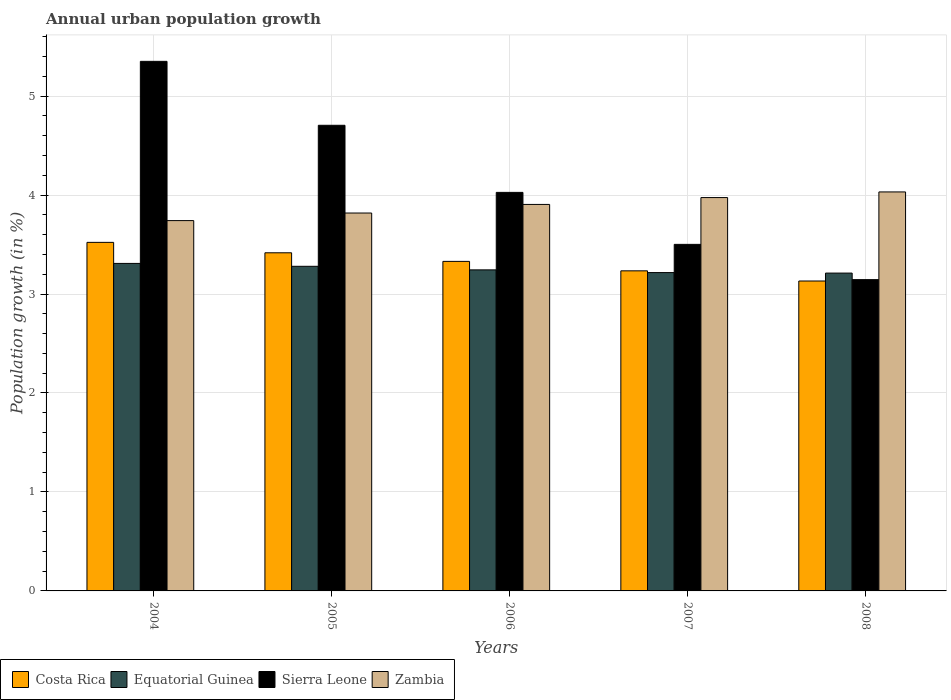How many different coloured bars are there?
Your response must be concise. 4. Are the number of bars on each tick of the X-axis equal?
Ensure brevity in your answer.  Yes. How many bars are there on the 5th tick from the right?
Provide a short and direct response. 4. What is the label of the 4th group of bars from the left?
Your answer should be very brief. 2007. What is the percentage of urban population growth in Zambia in 2007?
Offer a very short reply. 3.97. Across all years, what is the maximum percentage of urban population growth in Sierra Leone?
Offer a terse response. 5.35. Across all years, what is the minimum percentage of urban population growth in Zambia?
Make the answer very short. 3.74. What is the total percentage of urban population growth in Equatorial Guinea in the graph?
Your response must be concise. 16.26. What is the difference between the percentage of urban population growth in Sierra Leone in 2006 and that in 2007?
Your response must be concise. 0.53. What is the difference between the percentage of urban population growth in Equatorial Guinea in 2008 and the percentage of urban population growth in Costa Rica in 2005?
Your response must be concise. -0.21. What is the average percentage of urban population growth in Sierra Leone per year?
Make the answer very short. 4.15. In the year 2007, what is the difference between the percentage of urban population growth in Zambia and percentage of urban population growth in Costa Rica?
Your answer should be compact. 0.74. What is the ratio of the percentage of urban population growth in Sierra Leone in 2004 to that in 2006?
Offer a terse response. 1.33. Is the percentage of urban population growth in Zambia in 2004 less than that in 2008?
Your answer should be compact. Yes. What is the difference between the highest and the second highest percentage of urban population growth in Sierra Leone?
Give a very brief answer. 0.65. What is the difference between the highest and the lowest percentage of urban population growth in Costa Rica?
Your response must be concise. 0.39. Is the sum of the percentage of urban population growth in Zambia in 2006 and 2007 greater than the maximum percentage of urban population growth in Costa Rica across all years?
Give a very brief answer. Yes. What does the 3rd bar from the left in 2008 represents?
Provide a short and direct response. Sierra Leone. What does the 4th bar from the right in 2004 represents?
Your answer should be compact. Costa Rica. How many bars are there?
Ensure brevity in your answer.  20. Are the values on the major ticks of Y-axis written in scientific E-notation?
Offer a very short reply. No. What is the title of the graph?
Make the answer very short. Annual urban population growth. Does "Pakistan" appear as one of the legend labels in the graph?
Ensure brevity in your answer.  No. What is the label or title of the Y-axis?
Make the answer very short. Population growth (in %). What is the Population growth (in %) in Costa Rica in 2004?
Your answer should be very brief. 3.52. What is the Population growth (in %) of Equatorial Guinea in 2004?
Offer a terse response. 3.31. What is the Population growth (in %) of Sierra Leone in 2004?
Your answer should be compact. 5.35. What is the Population growth (in %) of Zambia in 2004?
Your answer should be compact. 3.74. What is the Population growth (in %) of Costa Rica in 2005?
Make the answer very short. 3.42. What is the Population growth (in %) of Equatorial Guinea in 2005?
Your response must be concise. 3.28. What is the Population growth (in %) in Sierra Leone in 2005?
Provide a succinct answer. 4.7. What is the Population growth (in %) of Zambia in 2005?
Your response must be concise. 3.82. What is the Population growth (in %) in Costa Rica in 2006?
Provide a succinct answer. 3.33. What is the Population growth (in %) in Equatorial Guinea in 2006?
Provide a succinct answer. 3.24. What is the Population growth (in %) of Sierra Leone in 2006?
Offer a terse response. 4.03. What is the Population growth (in %) in Zambia in 2006?
Offer a very short reply. 3.91. What is the Population growth (in %) of Costa Rica in 2007?
Provide a short and direct response. 3.23. What is the Population growth (in %) of Equatorial Guinea in 2007?
Your answer should be compact. 3.22. What is the Population growth (in %) of Sierra Leone in 2007?
Ensure brevity in your answer.  3.5. What is the Population growth (in %) of Zambia in 2007?
Give a very brief answer. 3.97. What is the Population growth (in %) of Costa Rica in 2008?
Offer a very short reply. 3.13. What is the Population growth (in %) in Equatorial Guinea in 2008?
Your answer should be very brief. 3.21. What is the Population growth (in %) of Sierra Leone in 2008?
Give a very brief answer. 3.15. What is the Population growth (in %) in Zambia in 2008?
Give a very brief answer. 4.03. Across all years, what is the maximum Population growth (in %) of Costa Rica?
Give a very brief answer. 3.52. Across all years, what is the maximum Population growth (in %) of Equatorial Guinea?
Your answer should be compact. 3.31. Across all years, what is the maximum Population growth (in %) of Sierra Leone?
Keep it short and to the point. 5.35. Across all years, what is the maximum Population growth (in %) of Zambia?
Provide a succinct answer. 4.03. Across all years, what is the minimum Population growth (in %) in Costa Rica?
Give a very brief answer. 3.13. Across all years, what is the minimum Population growth (in %) of Equatorial Guinea?
Your response must be concise. 3.21. Across all years, what is the minimum Population growth (in %) in Sierra Leone?
Offer a very short reply. 3.15. Across all years, what is the minimum Population growth (in %) in Zambia?
Offer a very short reply. 3.74. What is the total Population growth (in %) in Costa Rica in the graph?
Provide a short and direct response. 16.63. What is the total Population growth (in %) of Equatorial Guinea in the graph?
Make the answer very short. 16.26. What is the total Population growth (in %) of Sierra Leone in the graph?
Your response must be concise. 20.73. What is the total Population growth (in %) in Zambia in the graph?
Provide a succinct answer. 19.47. What is the difference between the Population growth (in %) in Costa Rica in 2004 and that in 2005?
Provide a succinct answer. 0.11. What is the difference between the Population growth (in %) in Equatorial Guinea in 2004 and that in 2005?
Offer a terse response. 0.03. What is the difference between the Population growth (in %) of Sierra Leone in 2004 and that in 2005?
Ensure brevity in your answer.  0.65. What is the difference between the Population growth (in %) of Zambia in 2004 and that in 2005?
Provide a succinct answer. -0.08. What is the difference between the Population growth (in %) of Costa Rica in 2004 and that in 2006?
Provide a succinct answer. 0.19. What is the difference between the Population growth (in %) of Equatorial Guinea in 2004 and that in 2006?
Keep it short and to the point. 0.07. What is the difference between the Population growth (in %) of Sierra Leone in 2004 and that in 2006?
Offer a very short reply. 1.32. What is the difference between the Population growth (in %) in Zambia in 2004 and that in 2006?
Your answer should be compact. -0.16. What is the difference between the Population growth (in %) of Costa Rica in 2004 and that in 2007?
Provide a succinct answer. 0.29. What is the difference between the Population growth (in %) in Equatorial Guinea in 2004 and that in 2007?
Your answer should be compact. 0.09. What is the difference between the Population growth (in %) in Sierra Leone in 2004 and that in 2007?
Ensure brevity in your answer.  1.85. What is the difference between the Population growth (in %) of Zambia in 2004 and that in 2007?
Offer a very short reply. -0.23. What is the difference between the Population growth (in %) in Costa Rica in 2004 and that in 2008?
Ensure brevity in your answer.  0.39. What is the difference between the Population growth (in %) in Equatorial Guinea in 2004 and that in 2008?
Make the answer very short. 0.1. What is the difference between the Population growth (in %) in Sierra Leone in 2004 and that in 2008?
Offer a terse response. 2.21. What is the difference between the Population growth (in %) in Zambia in 2004 and that in 2008?
Your answer should be very brief. -0.29. What is the difference between the Population growth (in %) in Costa Rica in 2005 and that in 2006?
Provide a succinct answer. 0.09. What is the difference between the Population growth (in %) in Equatorial Guinea in 2005 and that in 2006?
Keep it short and to the point. 0.04. What is the difference between the Population growth (in %) of Sierra Leone in 2005 and that in 2006?
Provide a short and direct response. 0.68. What is the difference between the Population growth (in %) in Zambia in 2005 and that in 2006?
Keep it short and to the point. -0.09. What is the difference between the Population growth (in %) in Costa Rica in 2005 and that in 2007?
Keep it short and to the point. 0.18. What is the difference between the Population growth (in %) in Equatorial Guinea in 2005 and that in 2007?
Ensure brevity in your answer.  0.06. What is the difference between the Population growth (in %) of Sierra Leone in 2005 and that in 2007?
Your answer should be compact. 1.2. What is the difference between the Population growth (in %) in Zambia in 2005 and that in 2007?
Offer a terse response. -0.16. What is the difference between the Population growth (in %) in Costa Rica in 2005 and that in 2008?
Offer a terse response. 0.29. What is the difference between the Population growth (in %) of Equatorial Guinea in 2005 and that in 2008?
Keep it short and to the point. 0.07. What is the difference between the Population growth (in %) in Sierra Leone in 2005 and that in 2008?
Your answer should be very brief. 1.56. What is the difference between the Population growth (in %) of Zambia in 2005 and that in 2008?
Provide a short and direct response. -0.21. What is the difference between the Population growth (in %) of Costa Rica in 2006 and that in 2007?
Provide a succinct answer. 0.1. What is the difference between the Population growth (in %) in Equatorial Guinea in 2006 and that in 2007?
Give a very brief answer. 0.03. What is the difference between the Population growth (in %) in Sierra Leone in 2006 and that in 2007?
Give a very brief answer. 0.53. What is the difference between the Population growth (in %) of Zambia in 2006 and that in 2007?
Your answer should be compact. -0.07. What is the difference between the Population growth (in %) in Costa Rica in 2006 and that in 2008?
Provide a succinct answer. 0.2. What is the difference between the Population growth (in %) in Equatorial Guinea in 2006 and that in 2008?
Keep it short and to the point. 0.03. What is the difference between the Population growth (in %) in Sierra Leone in 2006 and that in 2008?
Ensure brevity in your answer.  0.88. What is the difference between the Population growth (in %) in Zambia in 2006 and that in 2008?
Give a very brief answer. -0.13. What is the difference between the Population growth (in %) in Costa Rica in 2007 and that in 2008?
Make the answer very short. 0.1. What is the difference between the Population growth (in %) of Equatorial Guinea in 2007 and that in 2008?
Keep it short and to the point. 0.01. What is the difference between the Population growth (in %) of Sierra Leone in 2007 and that in 2008?
Your response must be concise. 0.36. What is the difference between the Population growth (in %) in Zambia in 2007 and that in 2008?
Give a very brief answer. -0.06. What is the difference between the Population growth (in %) of Costa Rica in 2004 and the Population growth (in %) of Equatorial Guinea in 2005?
Provide a succinct answer. 0.24. What is the difference between the Population growth (in %) of Costa Rica in 2004 and the Population growth (in %) of Sierra Leone in 2005?
Make the answer very short. -1.18. What is the difference between the Population growth (in %) of Costa Rica in 2004 and the Population growth (in %) of Zambia in 2005?
Ensure brevity in your answer.  -0.3. What is the difference between the Population growth (in %) in Equatorial Guinea in 2004 and the Population growth (in %) in Sierra Leone in 2005?
Offer a terse response. -1.4. What is the difference between the Population growth (in %) of Equatorial Guinea in 2004 and the Population growth (in %) of Zambia in 2005?
Offer a terse response. -0.51. What is the difference between the Population growth (in %) in Sierra Leone in 2004 and the Population growth (in %) in Zambia in 2005?
Provide a short and direct response. 1.53. What is the difference between the Population growth (in %) of Costa Rica in 2004 and the Population growth (in %) of Equatorial Guinea in 2006?
Offer a terse response. 0.28. What is the difference between the Population growth (in %) of Costa Rica in 2004 and the Population growth (in %) of Sierra Leone in 2006?
Your answer should be very brief. -0.51. What is the difference between the Population growth (in %) of Costa Rica in 2004 and the Population growth (in %) of Zambia in 2006?
Make the answer very short. -0.38. What is the difference between the Population growth (in %) of Equatorial Guinea in 2004 and the Population growth (in %) of Sierra Leone in 2006?
Offer a very short reply. -0.72. What is the difference between the Population growth (in %) in Equatorial Guinea in 2004 and the Population growth (in %) in Zambia in 2006?
Your answer should be very brief. -0.6. What is the difference between the Population growth (in %) of Sierra Leone in 2004 and the Population growth (in %) of Zambia in 2006?
Provide a succinct answer. 1.45. What is the difference between the Population growth (in %) in Costa Rica in 2004 and the Population growth (in %) in Equatorial Guinea in 2007?
Provide a succinct answer. 0.31. What is the difference between the Population growth (in %) of Costa Rica in 2004 and the Population growth (in %) of Sierra Leone in 2007?
Your answer should be very brief. 0.02. What is the difference between the Population growth (in %) in Costa Rica in 2004 and the Population growth (in %) in Zambia in 2007?
Ensure brevity in your answer.  -0.45. What is the difference between the Population growth (in %) of Equatorial Guinea in 2004 and the Population growth (in %) of Sierra Leone in 2007?
Make the answer very short. -0.19. What is the difference between the Population growth (in %) in Equatorial Guinea in 2004 and the Population growth (in %) in Zambia in 2007?
Provide a short and direct response. -0.67. What is the difference between the Population growth (in %) of Sierra Leone in 2004 and the Population growth (in %) of Zambia in 2007?
Your answer should be very brief. 1.38. What is the difference between the Population growth (in %) of Costa Rica in 2004 and the Population growth (in %) of Equatorial Guinea in 2008?
Provide a succinct answer. 0.31. What is the difference between the Population growth (in %) in Costa Rica in 2004 and the Population growth (in %) in Sierra Leone in 2008?
Offer a terse response. 0.38. What is the difference between the Population growth (in %) in Costa Rica in 2004 and the Population growth (in %) in Zambia in 2008?
Give a very brief answer. -0.51. What is the difference between the Population growth (in %) of Equatorial Guinea in 2004 and the Population growth (in %) of Sierra Leone in 2008?
Your response must be concise. 0.16. What is the difference between the Population growth (in %) of Equatorial Guinea in 2004 and the Population growth (in %) of Zambia in 2008?
Ensure brevity in your answer.  -0.72. What is the difference between the Population growth (in %) in Sierra Leone in 2004 and the Population growth (in %) in Zambia in 2008?
Ensure brevity in your answer.  1.32. What is the difference between the Population growth (in %) in Costa Rica in 2005 and the Population growth (in %) in Equatorial Guinea in 2006?
Make the answer very short. 0.17. What is the difference between the Population growth (in %) of Costa Rica in 2005 and the Population growth (in %) of Sierra Leone in 2006?
Offer a terse response. -0.61. What is the difference between the Population growth (in %) in Costa Rica in 2005 and the Population growth (in %) in Zambia in 2006?
Offer a terse response. -0.49. What is the difference between the Population growth (in %) in Equatorial Guinea in 2005 and the Population growth (in %) in Sierra Leone in 2006?
Your answer should be very brief. -0.75. What is the difference between the Population growth (in %) of Equatorial Guinea in 2005 and the Population growth (in %) of Zambia in 2006?
Provide a short and direct response. -0.63. What is the difference between the Population growth (in %) in Sierra Leone in 2005 and the Population growth (in %) in Zambia in 2006?
Make the answer very short. 0.8. What is the difference between the Population growth (in %) of Costa Rica in 2005 and the Population growth (in %) of Sierra Leone in 2007?
Your answer should be very brief. -0.09. What is the difference between the Population growth (in %) of Costa Rica in 2005 and the Population growth (in %) of Zambia in 2007?
Provide a succinct answer. -0.56. What is the difference between the Population growth (in %) in Equatorial Guinea in 2005 and the Population growth (in %) in Sierra Leone in 2007?
Keep it short and to the point. -0.22. What is the difference between the Population growth (in %) of Equatorial Guinea in 2005 and the Population growth (in %) of Zambia in 2007?
Your answer should be very brief. -0.69. What is the difference between the Population growth (in %) of Sierra Leone in 2005 and the Population growth (in %) of Zambia in 2007?
Keep it short and to the point. 0.73. What is the difference between the Population growth (in %) in Costa Rica in 2005 and the Population growth (in %) in Equatorial Guinea in 2008?
Ensure brevity in your answer.  0.2. What is the difference between the Population growth (in %) of Costa Rica in 2005 and the Population growth (in %) of Sierra Leone in 2008?
Offer a terse response. 0.27. What is the difference between the Population growth (in %) of Costa Rica in 2005 and the Population growth (in %) of Zambia in 2008?
Offer a terse response. -0.61. What is the difference between the Population growth (in %) in Equatorial Guinea in 2005 and the Population growth (in %) in Sierra Leone in 2008?
Offer a very short reply. 0.13. What is the difference between the Population growth (in %) in Equatorial Guinea in 2005 and the Population growth (in %) in Zambia in 2008?
Ensure brevity in your answer.  -0.75. What is the difference between the Population growth (in %) in Sierra Leone in 2005 and the Population growth (in %) in Zambia in 2008?
Your response must be concise. 0.67. What is the difference between the Population growth (in %) of Costa Rica in 2006 and the Population growth (in %) of Equatorial Guinea in 2007?
Offer a very short reply. 0.11. What is the difference between the Population growth (in %) in Costa Rica in 2006 and the Population growth (in %) in Sierra Leone in 2007?
Offer a very short reply. -0.17. What is the difference between the Population growth (in %) of Costa Rica in 2006 and the Population growth (in %) of Zambia in 2007?
Make the answer very short. -0.64. What is the difference between the Population growth (in %) in Equatorial Guinea in 2006 and the Population growth (in %) in Sierra Leone in 2007?
Offer a terse response. -0.26. What is the difference between the Population growth (in %) in Equatorial Guinea in 2006 and the Population growth (in %) in Zambia in 2007?
Give a very brief answer. -0.73. What is the difference between the Population growth (in %) in Sierra Leone in 2006 and the Population growth (in %) in Zambia in 2007?
Give a very brief answer. 0.05. What is the difference between the Population growth (in %) in Costa Rica in 2006 and the Population growth (in %) in Equatorial Guinea in 2008?
Make the answer very short. 0.12. What is the difference between the Population growth (in %) of Costa Rica in 2006 and the Population growth (in %) of Sierra Leone in 2008?
Your answer should be very brief. 0.18. What is the difference between the Population growth (in %) in Costa Rica in 2006 and the Population growth (in %) in Zambia in 2008?
Give a very brief answer. -0.7. What is the difference between the Population growth (in %) in Equatorial Guinea in 2006 and the Population growth (in %) in Sierra Leone in 2008?
Your response must be concise. 0.1. What is the difference between the Population growth (in %) in Equatorial Guinea in 2006 and the Population growth (in %) in Zambia in 2008?
Your response must be concise. -0.79. What is the difference between the Population growth (in %) in Sierra Leone in 2006 and the Population growth (in %) in Zambia in 2008?
Give a very brief answer. -0. What is the difference between the Population growth (in %) in Costa Rica in 2007 and the Population growth (in %) in Equatorial Guinea in 2008?
Keep it short and to the point. 0.02. What is the difference between the Population growth (in %) in Costa Rica in 2007 and the Population growth (in %) in Sierra Leone in 2008?
Your answer should be compact. 0.09. What is the difference between the Population growth (in %) of Costa Rica in 2007 and the Population growth (in %) of Zambia in 2008?
Offer a terse response. -0.8. What is the difference between the Population growth (in %) in Equatorial Guinea in 2007 and the Population growth (in %) in Sierra Leone in 2008?
Your response must be concise. 0.07. What is the difference between the Population growth (in %) of Equatorial Guinea in 2007 and the Population growth (in %) of Zambia in 2008?
Your answer should be very brief. -0.81. What is the difference between the Population growth (in %) of Sierra Leone in 2007 and the Population growth (in %) of Zambia in 2008?
Provide a short and direct response. -0.53. What is the average Population growth (in %) in Costa Rica per year?
Offer a terse response. 3.33. What is the average Population growth (in %) in Equatorial Guinea per year?
Provide a short and direct response. 3.25. What is the average Population growth (in %) of Sierra Leone per year?
Give a very brief answer. 4.15. What is the average Population growth (in %) of Zambia per year?
Your answer should be compact. 3.89. In the year 2004, what is the difference between the Population growth (in %) of Costa Rica and Population growth (in %) of Equatorial Guinea?
Make the answer very short. 0.21. In the year 2004, what is the difference between the Population growth (in %) of Costa Rica and Population growth (in %) of Sierra Leone?
Your answer should be very brief. -1.83. In the year 2004, what is the difference between the Population growth (in %) in Costa Rica and Population growth (in %) in Zambia?
Your answer should be very brief. -0.22. In the year 2004, what is the difference between the Population growth (in %) of Equatorial Guinea and Population growth (in %) of Sierra Leone?
Make the answer very short. -2.04. In the year 2004, what is the difference between the Population growth (in %) of Equatorial Guinea and Population growth (in %) of Zambia?
Keep it short and to the point. -0.43. In the year 2004, what is the difference between the Population growth (in %) of Sierra Leone and Population growth (in %) of Zambia?
Ensure brevity in your answer.  1.61. In the year 2005, what is the difference between the Population growth (in %) of Costa Rica and Population growth (in %) of Equatorial Guinea?
Make the answer very short. 0.14. In the year 2005, what is the difference between the Population growth (in %) of Costa Rica and Population growth (in %) of Sierra Leone?
Offer a very short reply. -1.29. In the year 2005, what is the difference between the Population growth (in %) of Costa Rica and Population growth (in %) of Zambia?
Ensure brevity in your answer.  -0.4. In the year 2005, what is the difference between the Population growth (in %) in Equatorial Guinea and Population growth (in %) in Sierra Leone?
Your answer should be compact. -1.42. In the year 2005, what is the difference between the Population growth (in %) of Equatorial Guinea and Population growth (in %) of Zambia?
Offer a very short reply. -0.54. In the year 2005, what is the difference between the Population growth (in %) in Sierra Leone and Population growth (in %) in Zambia?
Your answer should be very brief. 0.89. In the year 2006, what is the difference between the Population growth (in %) of Costa Rica and Population growth (in %) of Equatorial Guinea?
Keep it short and to the point. 0.09. In the year 2006, what is the difference between the Population growth (in %) of Costa Rica and Population growth (in %) of Sierra Leone?
Ensure brevity in your answer.  -0.7. In the year 2006, what is the difference between the Population growth (in %) in Costa Rica and Population growth (in %) in Zambia?
Keep it short and to the point. -0.58. In the year 2006, what is the difference between the Population growth (in %) in Equatorial Guinea and Population growth (in %) in Sierra Leone?
Provide a short and direct response. -0.78. In the year 2006, what is the difference between the Population growth (in %) of Equatorial Guinea and Population growth (in %) of Zambia?
Provide a succinct answer. -0.66. In the year 2006, what is the difference between the Population growth (in %) in Sierra Leone and Population growth (in %) in Zambia?
Make the answer very short. 0.12. In the year 2007, what is the difference between the Population growth (in %) of Costa Rica and Population growth (in %) of Equatorial Guinea?
Your answer should be very brief. 0.02. In the year 2007, what is the difference between the Population growth (in %) of Costa Rica and Population growth (in %) of Sierra Leone?
Your response must be concise. -0.27. In the year 2007, what is the difference between the Population growth (in %) of Costa Rica and Population growth (in %) of Zambia?
Give a very brief answer. -0.74. In the year 2007, what is the difference between the Population growth (in %) in Equatorial Guinea and Population growth (in %) in Sierra Leone?
Keep it short and to the point. -0.29. In the year 2007, what is the difference between the Population growth (in %) of Equatorial Guinea and Population growth (in %) of Zambia?
Offer a very short reply. -0.76. In the year 2007, what is the difference between the Population growth (in %) in Sierra Leone and Population growth (in %) in Zambia?
Provide a succinct answer. -0.47. In the year 2008, what is the difference between the Population growth (in %) in Costa Rica and Population growth (in %) in Equatorial Guinea?
Keep it short and to the point. -0.08. In the year 2008, what is the difference between the Population growth (in %) in Costa Rica and Population growth (in %) in Sierra Leone?
Your answer should be compact. -0.01. In the year 2008, what is the difference between the Population growth (in %) in Costa Rica and Population growth (in %) in Zambia?
Keep it short and to the point. -0.9. In the year 2008, what is the difference between the Population growth (in %) of Equatorial Guinea and Population growth (in %) of Sierra Leone?
Offer a very short reply. 0.07. In the year 2008, what is the difference between the Population growth (in %) of Equatorial Guinea and Population growth (in %) of Zambia?
Your answer should be compact. -0.82. In the year 2008, what is the difference between the Population growth (in %) of Sierra Leone and Population growth (in %) of Zambia?
Your answer should be very brief. -0.89. What is the ratio of the Population growth (in %) of Costa Rica in 2004 to that in 2005?
Offer a terse response. 1.03. What is the ratio of the Population growth (in %) of Equatorial Guinea in 2004 to that in 2005?
Provide a succinct answer. 1.01. What is the ratio of the Population growth (in %) in Sierra Leone in 2004 to that in 2005?
Offer a terse response. 1.14. What is the ratio of the Population growth (in %) in Zambia in 2004 to that in 2005?
Provide a short and direct response. 0.98. What is the ratio of the Population growth (in %) of Costa Rica in 2004 to that in 2006?
Provide a succinct answer. 1.06. What is the ratio of the Population growth (in %) in Equatorial Guinea in 2004 to that in 2006?
Offer a very short reply. 1.02. What is the ratio of the Population growth (in %) in Sierra Leone in 2004 to that in 2006?
Your answer should be compact. 1.33. What is the ratio of the Population growth (in %) in Zambia in 2004 to that in 2006?
Ensure brevity in your answer.  0.96. What is the ratio of the Population growth (in %) in Costa Rica in 2004 to that in 2007?
Provide a succinct answer. 1.09. What is the ratio of the Population growth (in %) in Equatorial Guinea in 2004 to that in 2007?
Provide a succinct answer. 1.03. What is the ratio of the Population growth (in %) of Sierra Leone in 2004 to that in 2007?
Offer a terse response. 1.53. What is the ratio of the Population growth (in %) in Zambia in 2004 to that in 2007?
Provide a succinct answer. 0.94. What is the ratio of the Population growth (in %) in Costa Rica in 2004 to that in 2008?
Your answer should be very brief. 1.12. What is the ratio of the Population growth (in %) of Equatorial Guinea in 2004 to that in 2008?
Make the answer very short. 1.03. What is the ratio of the Population growth (in %) of Sierra Leone in 2004 to that in 2008?
Keep it short and to the point. 1.7. What is the ratio of the Population growth (in %) of Zambia in 2004 to that in 2008?
Your answer should be compact. 0.93. What is the ratio of the Population growth (in %) of Costa Rica in 2005 to that in 2006?
Your response must be concise. 1.03. What is the ratio of the Population growth (in %) of Equatorial Guinea in 2005 to that in 2006?
Give a very brief answer. 1.01. What is the ratio of the Population growth (in %) in Sierra Leone in 2005 to that in 2006?
Your answer should be compact. 1.17. What is the ratio of the Population growth (in %) of Zambia in 2005 to that in 2006?
Provide a succinct answer. 0.98. What is the ratio of the Population growth (in %) of Costa Rica in 2005 to that in 2007?
Offer a terse response. 1.06. What is the ratio of the Population growth (in %) in Equatorial Guinea in 2005 to that in 2007?
Your response must be concise. 1.02. What is the ratio of the Population growth (in %) in Sierra Leone in 2005 to that in 2007?
Make the answer very short. 1.34. What is the ratio of the Population growth (in %) of Zambia in 2005 to that in 2007?
Keep it short and to the point. 0.96. What is the ratio of the Population growth (in %) in Costa Rica in 2005 to that in 2008?
Provide a short and direct response. 1.09. What is the ratio of the Population growth (in %) of Equatorial Guinea in 2005 to that in 2008?
Offer a very short reply. 1.02. What is the ratio of the Population growth (in %) of Sierra Leone in 2005 to that in 2008?
Your answer should be compact. 1.5. What is the ratio of the Population growth (in %) in Zambia in 2005 to that in 2008?
Provide a short and direct response. 0.95. What is the ratio of the Population growth (in %) of Costa Rica in 2006 to that in 2007?
Provide a short and direct response. 1.03. What is the ratio of the Population growth (in %) of Equatorial Guinea in 2006 to that in 2007?
Your answer should be compact. 1.01. What is the ratio of the Population growth (in %) in Sierra Leone in 2006 to that in 2007?
Your response must be concise. 1.15. What is the ratio of the Population growth (in %) of Zambia in 2006 to that in 2007?
Give a very brief answer. 0.98. What is the ratio of the Population growth (in %) in Costa Rica in 2006 to that in 2008?
Give a very brief answer. 1.06. What is the ratio of the Population growth (in %) in Sierra Leone in 2006 to that in 2008?
Ensure brevity in your answer.  1.28. What is the ratio of the Population growth (in %) in Zambia in 2006 to that in 2008?
Ensure brevity in your answer.  0.97. What is the ratio of the Population growth (in %) of Costa Rica in 2007 to that in 2008?
Your answer should be compact. 1.03. What is the ratio of the Population growth (in %) in Equatorial Guinea in 2007 to that in 2008?
Your answer should be very brief. 1. What is the ratio of the Population growth (in %) in Sierra Leone in 2007 to that in 2008?
Ensure brevity in your answer.  1.11. What is the ratio of the Population growth (in %) of Zambia in 2007 to that in 2008?
Provide a succinct answer. 0.99. What is the difference between the highest and the second highest Population growth (in %) of Costa Rica?
Ensure brevity in your answer.  0.11. What is the difference between the highest and the second highest Population growth (in %) of Equatorial Guinea?
Make the answer very short. 0.03. What is the difference between the highest and the second highest Population growth (in %) in Sierra Leone?
Ensure brevity in your answer.  0.65. What is the difference between the highest and the second highest Population growth (in %) of Zambia?
Your answer should be very brief. 0.06. What is the difference between the highest and the lowest Population growth (in %) in Costa Rica?
Make the answer very short. 0.39. What is the difference between the highest and the lowest Population growth (in %) in Equatorial Guinea?
Provide a short and direct response. 0.1. What is the difference between the highest and the lowest Population growth (in %) of Sierra Leone?
Make the answer very short. 2.21. What is the difference between the highest and the lowest Population growth (in %) in Zambia?
Provide a short and direct response. 0.29. 